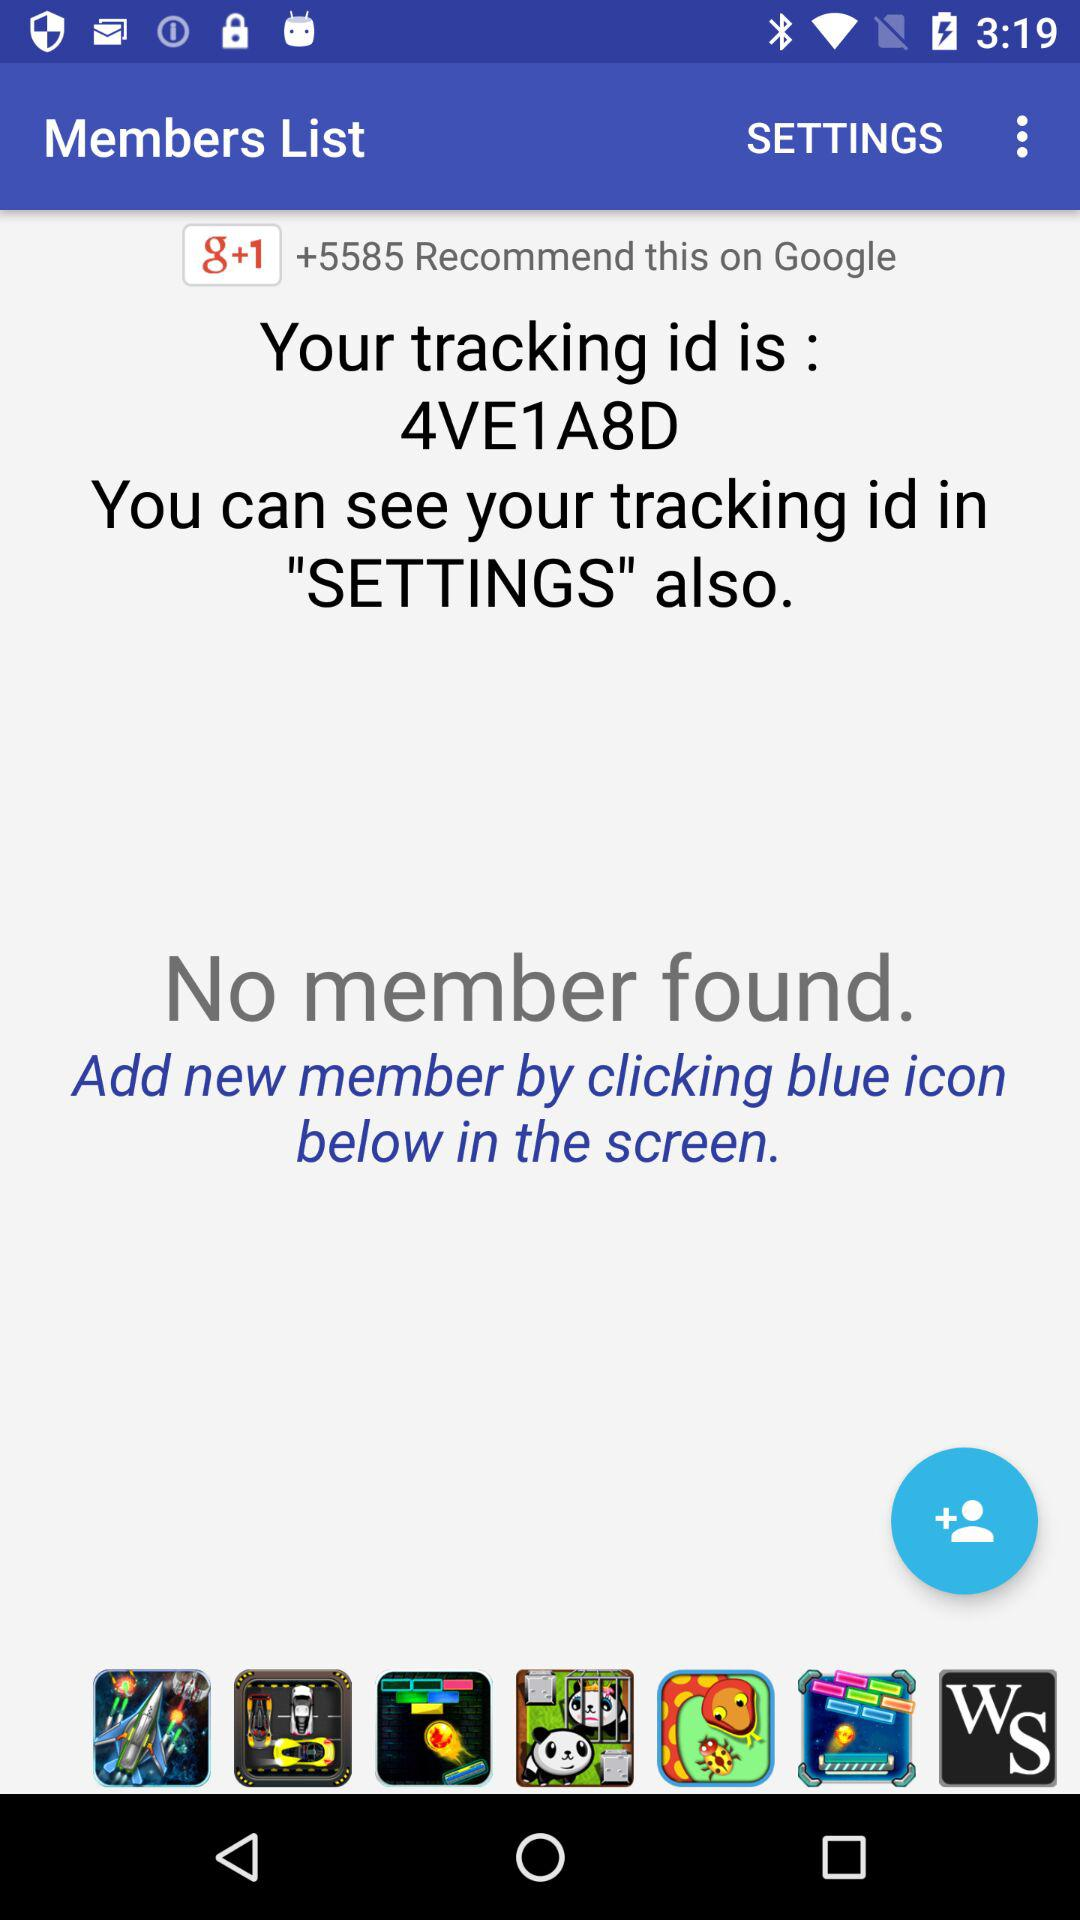Are there any members found? There are no members found. 